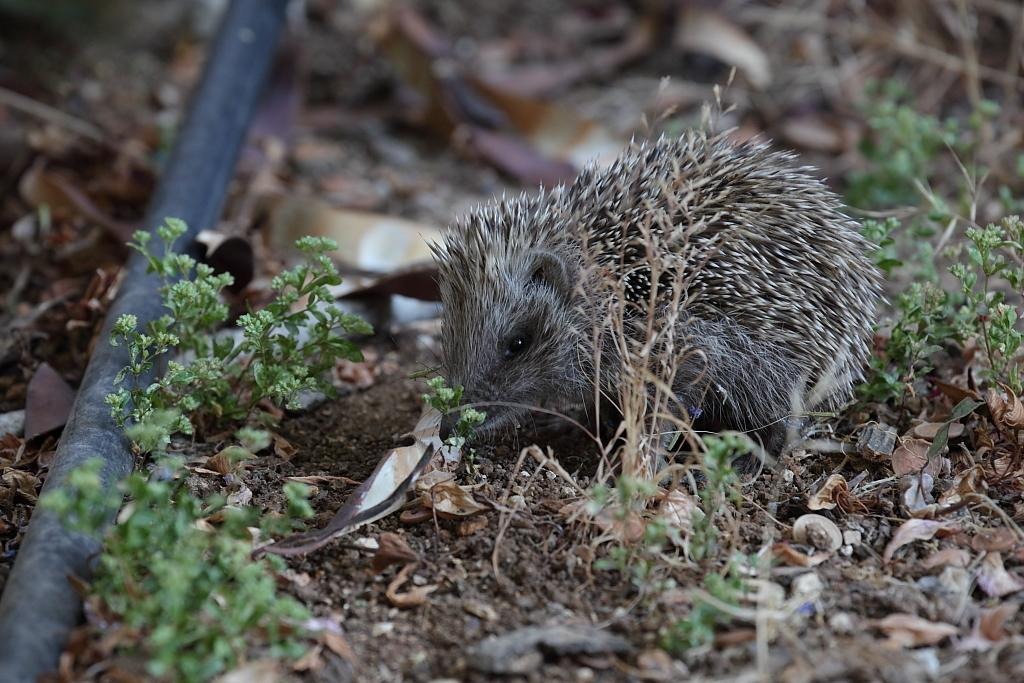What animal is present in the image? There is a rat in the image. Where is the rat located in the image? The rat is on the land in the image. What type of vegetation can be seen in the image? There is grass visible in the image. What type of knot can be seen in the image? There is no knot present in the image; it features a rat on the land with grass visible. 